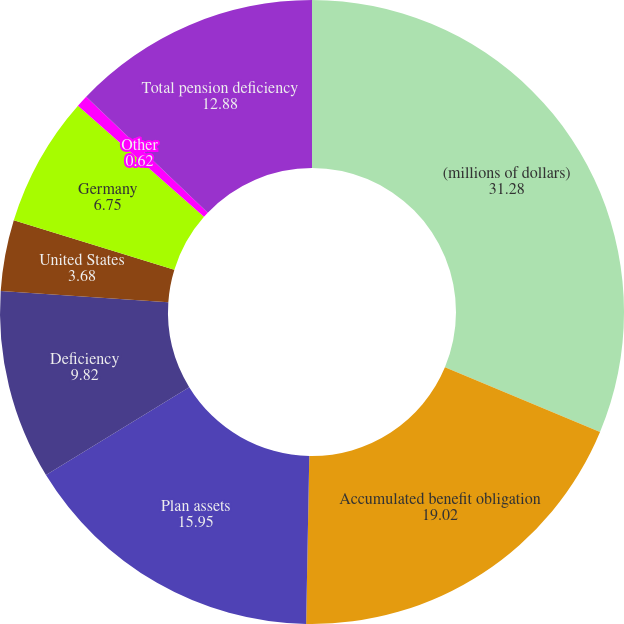<chart> <loc_0><loc_0><loc_500><loc_500><pie_chart><fcel>(millions of dollars)<fcel>Accumulated benefit obligation<fcel>Plan assets<fcel>Deficiency<fcel>United States<fcel>Germany<fcel>Other<fcel>Total pension deficiency<nl><fcel>31.28%<fcel>19.02%<fcel>15.95%<fcel>9.82%<fcel>3.68%<fcel>6.75%<fcel>0.62%<fcel>12.88%<nl></chart> 